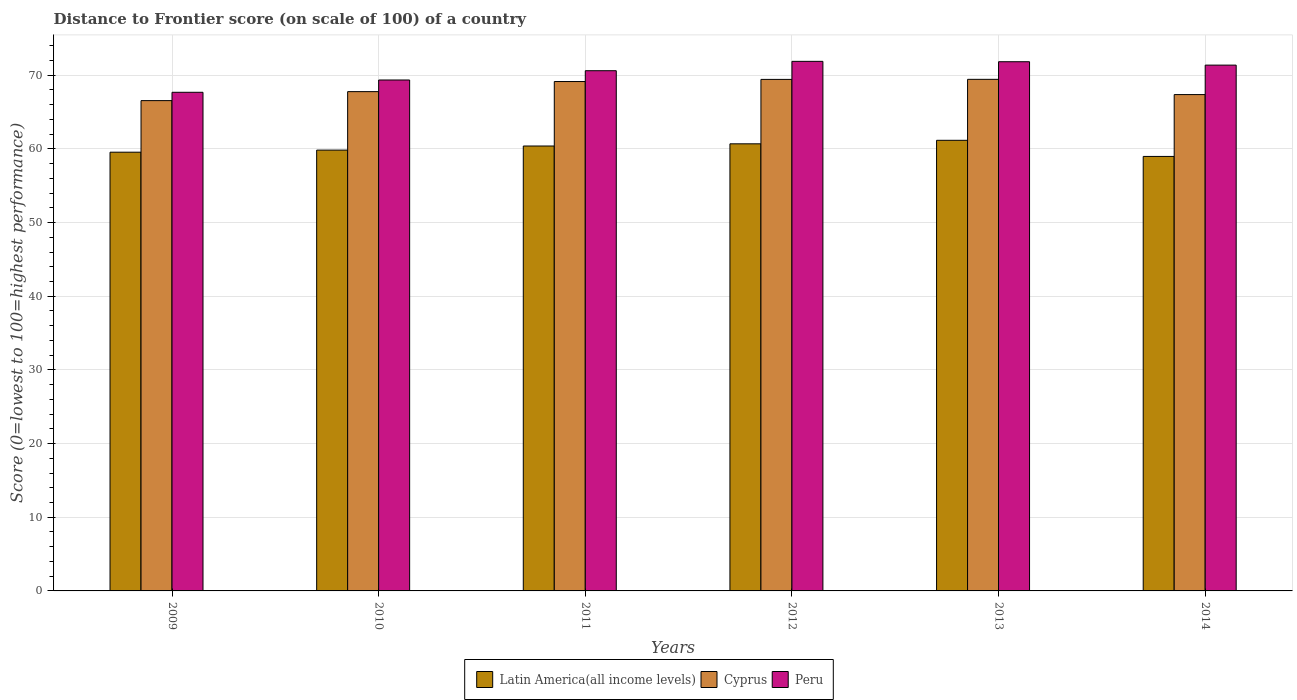How many different coloured bars are there?
Offer a very short reply. 3. How many groups of bars are there?
Offer a terse response. 6. How many bars are there on the 3rd tick from the left?
Provide a short and direct response. 3. How many bars are there on the 6th tick from the right?
Provide a succinct answer. 3. In how many cases, is the number of bars for a given year not equal to the number of legend labels?
Ensure brevity in your answer.  0. What is the distance to frontier score of in Latin America(all income levels) in 2012?
Offer a very short reply. 60.69. Across all years, what is the maximum distance to frontier score of in Peru?
Ensure brevity in your answer.  71.88. Across all years, what is the minimum distance to frontier score of in Peru?
Ensure brevity in your answer.  67.68. In which year was the distance to frontier score of in Latin America(all income levels) maximum?
Your answer should be very brief. 2013. What is the total distance to frontier score of in Cyprus in the graph?
Make the answer very short. 409.7. What is the difference between the distance to frontier score of in Peru in 2009 and that in 2014?
Provide a succinct answer. -3.69. What is the difference between the distance to frontier score of in Latin America(all income levels) in 2010 and the distance to frontier score of in Peru in 2012?
Provide a short and direct response. -12.05. What is the average distance to frontier score of in Latin America(all income levels) per year?
Offer a very short reply. 60.1. In the year 2012, what is the difference between the distance to frontier score of in Peru and distance to frontier score of in Latin America(all income levels)?
Provide a succinct answer. 11.19. In how many years, is the distance to frontier score of in Latin America(all income levels) greater than 68?
Offer a terse response. 0. What is the ratio of the distance to frontier score of in Peru in 2012 to that in 2014?
Your response must be concise. 1.01. Is the difference between the distance to frontier score of in Peru in 2009 and 2011 greater than the difference between the distance to frontier score of in Latin America(all income levels) in 2009 and 2011?
Your response must be concise. No. What is the difference between the highest and the second highest distance to frontier score of in Peru?
Ensure brevity in your answer.  0.05. What is the difference between the highest and the lowest distance to frontier score of in Peru?
Your answer should be very brief. 4.2. In how many years, is the distance to frontier score of in Latin America(all income levels) greater than the average distance to frontier score of in Latin America(all income levels) taken over all years?
Your answer should be very brief. 3. What does the 3rd bar from the left in 2011 represents?
Your response must be concise. Peru. What does the 3rd bar from the right in 2013 represents?
Your answer should be very brief. Latin America(all income levels). Is it the case that in every year, the sum of the distance to frontier score of in Latin America(all income levels) and distance to frontier score of in Peru is greater than the distance to frontier score of in Cyprus?
Ensure brevity in your answer.  Yes. How many bars are there?
Provide a short and direct response. 18. Are all the bars in the graph horizontal?
Give a very brief answer. No. How many years are there in the graph?
Offer a terse response. 6. What is the difference between two consecutive major ticks on the Y-axis?
Your response must be concise. 10. Are the values on the major ticks of Y-axis written in scientific E-notation?
Provide a succinct answer. No. Does the graph contain grids?
Offer a terse response. Yes. Where does the legend appear in the graph?
Your answer should be very brief. Bottom center. How are the legend labels stacked?
Provide a short and direct response. Horizontal. What is the title of the graph?
Make the answer very short. Distance to Frontier score (on scale of 100) of a country. What is the label or title of the Y-axis?
Your answer should be compact. Score (0=lowest to 100=highest performance). What is the Score (0=lowest to 100=highest performance) of Latin America(all income levels) in 2009?
Give a very brief answer. 59.55. What is the Score (0=lowest to 100=highest performance) in Cyprus in 2009?
Your answer should be very brief. 66.55. What is the Score (0=lowest to 100=highest performance) in Peru in 2009?
Give a very brief answer. 67.68. What is the Score (0=lowest to 100=highest performance) in Latin America(all income levels) in 2010?
Keep it short and to the point. 59.83. What is the Score (0=lowest to 100=highest performance) in Cyprus in 2010?
Make the answer very short. 67.77. What is the Score (0=lowest to 100=highest performance) of Peru in 2010?
Give a very brief answer. 69.35. What is the Score (0=lowest to 100=highest performance) in Latin America(all income levels) in 2011?
Provide a short and direct response. 60.39. What is the Score (0=lowest to 100=highest performance) in Cyprus in 2011?
Your response must be concise. 69.14. What is the Score (0=lowest to 100=highest performance) of Peru in 2011?
Offer a terse response. 70.61. What is the Score (0=lowest to 100=highest performance) of Latin America(all income levels) in 2012?
Your response must be concise. 60.69. What is the Score (0=lowest to 100=highest performance) of Cyprus in 2012?
Your answer should be very brief. 69.43. What is the Score (0=lowest to 100=highest performance) in Peru in 2012?
Provide a short and direct response. 71.88. What is the Score (0=lowest to 100=highest performance) in Latin America(all income levels) in 2013?
Make the answer very short. 61.16. What is the Score (0=lowest to 100=highest performance) in Cyprus in 2013?
Offer a very short reply. 69.44. What is the Score (0=lowest to 100=highest performance) in Peru in 2013?
Offer a terse response. 71.83. What is the Score (0=lowest to 100=highest performance) of Latin America(all income levels) in 2014?
Make the answer very short. 58.97. What is the Score (0=lowest to 100=highest performance) of Cyprus in 2014?
Make the answer very short. 67.37. What is the Score (0=lowest to 100=highest performance) in Peru in 2014?
Offer a terse response. 71.37. Across all years, what is the maximum Score (0=lowest to 100=highest performance) of Latin America(all income levels)?
Your response must be concise. 61.16. Across all years, what is the maximum Score (0=lowest to 100=highest performance) in Cyprus?
Give a very brief answer. 69.44. Across all years, what is the maximum Score (0=lowest to 100=highest performance) in Peru?
Keep it short and to the point. 71.88. Across all years, what is the minimum Score (0=lowest to 100=highest performance) in Latin America(all income levels)?
Your answer should be very brief. 58.97. Across all years, what is the minimum Score (0=lowest to 100=highest performance) in Cyprus?
Offer a terse response. 66.55. Across all years, what is the minimum Score (0=lowest to 100=highest performance) in Peru?
Offer a very short reply. 67.68. What is the total Score (0=lowest to 100=highest performance) in Latin America(all income levels) in the graph?
Ensure brevity in your answer.  360.6. What is the total Score (0=lowest to 100=highest performance) in Cyprus in the graph?
Your answer should be very brief. 409.7. What is the total Score (0=lowest to 100=highest performance) in Peru in the graph?
Your answer should be compact. 422.72. What is the difference between the Score (0=lowest to 100=highest performance) of Latin America(all income levels) in 2009 and that in 2010?
Offer a terse response. -0.28. What is the difference between the Score (0=lowest to 100=highest performance) of Cyprus in 2009 and that in 2010?
Offer a terse response. -1.22. What is the difference between the Score (0=lowest to 100=highest performance) of Peru in 2009 and that in 2010?
Offer a terse response. -1.67. What is the difference between the Score (0=lowest to 100=highest performance) of Latin America(all income levels) in 2009 and that in 2011?
Your answer should be compact. -0.84. What is the difference between the Score (0=lowest to 100=highest performance) in Cyprus in 2009 and that in 2011?
Ensure brevity in your answer.  -2.59. What is the difference between the Score (0=lowest to 100=highest performance) in Peru in 2009 and that in 2011?
Offer a terse response. -2.93. What is the difference between the Score (0=lowest to 100=highest performance) of Latin America(all income levels) in 2009 and that in 2012?
Provide a succinct answer. -1.14. What is the difference between the Score (0=lowest to 100=highest performance) in Cyprus in 2009 and that in 2012?
Provide a succinct answer. -2.88. What is the difference between the Score (0=lowest to 100=highest performance) in Peru in 2009 and that in 2012?
Make the answer very short. -4.2. What is the difference between the Score (0=lowest to 100=highest performance) in Latin America(all income levels) in 2009 and that in 2013?
Make the answer very short. -1.61. What is the difference between the Score (0=lowest to 100=highest performance) in Cyprus in 2009 and that in 2013?
Your response must be concise. -2.89. What is the difference between the Score (0=lowest to 100=highest performance) of Peru in 2009 and that in 2013?
Give a very brief answer. -4.15. What is the difference between the Score (0=lowest to 100=highest performance) of Latin America(all income levels) in 2009 and that in 2014?
Give a very brief answer. 0.57. What is the difference between the Score (0=lowest to 100=highest performance) in Cyprus in 2009 and that in 2014?
Provide a short and direct response. -0.82. What is the difference between the Score (0=lowest to 100=highest performance) in Peru in 2009 and that in 2014?
Your answer should be very brief. -3.69. What is the difference between the Score (0=lowest to 100=highest performance) of Latin America(all income levels) in 2010 and that in 2011?
Provide a succinct answer. -0.56. What is the difference between the Score (0=lowest to 100=highest performance) of Cyprus in 2010 and that in 2011?
Keep it short and to the point. -1.37. What is the difference between the Score (0=lowest to 100=highest performance) of Peru in 2010 and that in 2011?
Your answer should be compact. -1.26. What is the difference between the Score (0=lowest to 100=highest performance) of Latin America(all income levels) in 2010 and that in 2012?
Your answer should be compact. -0.85. What is the difference between the Score (0=lowest to 100=highest performance) in Cyprus in 2010 and that in 2012?
Your response must be concise. -1.66. What is the difference between the Score (0=lowest to 100=highest performance) in Peru in 2010 and that in 2012?
Your response must be concise. -2.53. What is the difference between the Score (0=lowest to 100=highest performance) in Latin America(all income levels) in 2010 and that in 2013?
Keep it short and to the point. -1.33. What is the difference between the Score (0=lowest to 100=highest performance) of Cyprus in 2010 and that in 2013?
Your response must be concise. -1.67. What is the difference between the Score (0=lowest to 100=highest performance) of Peru in 2010 and that in 2013?
Your answer should be very brief. -2.48. What is the difference between the Score (0=lowest to 100=highest performance) in Latin America(all income levels) in 2010 and that in 2014?
Make the answer very short. 0.86. What is the difference between the Score (0=lowest to 100=highest performance) in Cyprus in 2010 and that in 2014?
Offer a terse response. 0.4. What is the difference between the Score (0=lowest to 100=highest performance) of Peru in 2010 and that in 2014?
Offer a terse response. -2.02. What is the difference between the Score (0=lowest to 100=highest performance) in Latin America(all income levels) in 2011 and that in 2012?
Offer a terse response. -0.3. What is the difference between the Score (0=lowest to 100=highest performance) in Cyprus in 2011 and that in 2012?
Your response must be concise. -0.29. What is the difference between the Score (0=lowest to 100=highest performance) in Peru in 2011 and that in 2012?
Your response must be concise. -1.27. What is the difference between the Score (0=lowest to 100=highest performance) of Latin America(all income levels) in 2011 and that in 2013?
Provide a succinct answer. -0.77. What is the difference between the Score (0=lowest to 100=highest performance) in Peru in 2011 and that in 2013?
Your response must be concise. -1.22. What is the difference between the Score (0=lowest to 100=highest performance) in Latin America(all income levels) in 2011 and that in 2014?
Ensure brevity in your answer.  1.42. What is the difference between the Score (0=lowest to 100=highest performance) of Cyprus in 2011 and that in 2014?
Provide a succinct answer. 1.77. What is the difference between the Score (0=lowest to 100=highest performance) of Peru in 2011 and that in 2014?
Your response must be concise. -0.76. What is the difference between the Score (0=lowest to 100=highest performance) of Latin America(all income levels) in 2012 and that in 2013?
Your answer should be very brief. -0.48. What is the difference between the Score (0=lowest to 100=highest performance) in Cyprus in 2012 and that in 2013?
Give a very brief answer. -0.01. What is the difference between the Score (0=lowest to 100=highest performance) in Peru in 2012 and that in 2013?
Your response must be concise. 0.05. What is the difference between the Score (0=lowest to 100=highest performance) of Latin America(all income levels) in 2012 and that in 2014?
Ensure brevity in your answer.  1.71. What is the difference between the Score (0=lowest to 100=highest performance) in Cyprus in 2012 and that in 2014?
Give a very brief answer. 2.06. What is the difference between the Score (0=lowest to 100=highest performance) of Peru in 2012 and that in 2014?
Provide a succinct answer. 0.51. What is the difference between the Score (0=lowest to 100=highest performance) in Latin America(all income levels) in 2013 and that in 2014?
Offer a very short reply. 2.19. What is the difference between the Score (0=lowest to 100=highest performance) in Cyprus in 2013 and that in 2014?
Your response must be concise. 2.07. What is the difference between the Score (0=lowest to 100=highest performance) in Peru in 2013 and that in 2014?
Provide a succinct answer. 0.46. What is the difference between the Score (0=lowest to 100=highest performance) of Latin America(all income levels) in 2009 and the Score (0=lowest to 100=highest performance) of Cyprus in 2010?
Offer a terse response. -8.22. What is the difference between the Score (0=lowest to 100=highest performance) in Latin America(all income levels) in 2009 and the Score (0=lowest to 100=highest performance) in Peru in 2010?
Offer a very short reply. -9.8. What is the difference between the Score (0=lowest to 100=highest performance) of Cyprus in 2009 and the Score (0=lowest to 100=highest performance) of Peru in 2010?
Offer a very short reply. -2.8. What is the difference between the Score (0=lowest to 100=highest performance) of Latin America(all income levels) in 2009 and the Score (0=lowest to 100=highest performance) of Cyprus in 2011?
Your answer should be compact. -9.59. What is the difference between the Score (0=lowest to 100=highest performance) of Latin America(all income levels) in 2009 and the Score (0=lowest to 100=highest performance) of Peru in 2011?
Provide a succinct answer. -11.06. What is the difference between the Score (0=lowest to 100=highest performance) of Cyprus in 2009 and the Score (0=lowest to 100=highest performance) of Peru in 2011?
Keep it short and to the point. -4.06. What is the difference between the Score (0=lowest to 100=highest performance) in Latin America(all income levels) in 2009 and the Score (0=lowest to 100=highest performance) in Cyprus in 2012?
Your response must be concise. -9.88. What is the difference between the Score (0=lowest to 100=highest performance) in Latin America(all income levels) in 2009 and the Score (0=lowest to 100=highest performance) in Peru in 2012?
Provide a succinct answer. -12.33. What is the difference between the Score (0=lowest to 100=highest performance) of Cyprus in 2009 and the Score (0=lowest to 100=highest performance) of Peru in 2012?
Ensure brevity in your answer.  -5.33. What is the difference between the Score (0=lowest to 100=highest performance) in Latin America(all income levels) in 2009 and the Score (0=lowest to 100=highest performance) in Cyprus in 2013?
Provide a short and direct response. -9.89. What is the difference between the Score (0=lowest to 100=highest performance) in Latin America(all income levels) in 2009 and the Score (0=lowest to 100=highest performance) in Peru in 2013?
Provide a succinct answer. -12.28. What is the difference between the Score (0=lowest to 100=highest performance) of Cyprus in 2009 and the Score (0=lowest to 100=highest performance) of Peru in 2013?
Your response must be concise. -5.28. What is the difference between the Score (0=lowest to 100=highest performance) in Latin America(all income levels) in 2009 and the Score (0=lowest to 100=highest performance) in Cyprus in 2014?
Make the answer very short. -7.82. What is the difference between the Score (0=lowest to 100=highest performance) of Latin America(all income levels) in 2009 and the Score (0=lowest to 100=highest performance) of Peru in 2014?
Provide a short and direct response. -11.82. What is the difference between the Score (0=lowest to 100=highest performance) of Cyprus in 2009 and the Score (0=lowest to 100=highest performance) of Peru in 2014?
Make the answer very short. -4.82. What is the difference between the Score (0=lowest to 100=highest performance) of Latin America(all income levels) in 2010 and the Score (0=lowest to 100=highest performance) of Cyprus in 2011?
Ensure brevity in your answer.  -9.31. What is the difference between the Score (0=lowest to 100=highest performance) in Latin America(all income levels) in 2010 and the Score (0=lowest to 100=highest performance) in Peru in 2011?
Offer a very short reply. -10.78. What is the difference between the Score (0=lowest to 100=highest performance) of Cyprus in 2010 and the Score (0=lowest to 100=highest performance) of Peru in 2011?
Your answer should be compact. -2.84. What is the difference between the Score (0=lowest to 100=highest performance) in Latin America(all income levels) in 2010 and the Score (0=lowest to 100=highest performance) in Cyprus in 2012?
Keep it short and to the point. -9.6. What is the difference between the Score (0=lowest to 100=highest performance) of Latin America(all income levels) in 2010 and the Score (0=lowest to 100=highest performance) of Peru in 2012?
Give a very brief answer. -12.05. What is the difference between the Score (0=lowest to 100=highest performance) of Cyprus in 2010 and the Score (0=lowest to 100=highest performance) of Peru in 2012?
Offer a very short reply. -4.11. What is the difference between the Score (0=lowest to 100=highest performance) of Latin America(all income levels) in 2010 and the Score (0=lowest to 100=highest performance) of Cyprus in 2013?
Provide a succinct answer. -9.61. What is the difference between the Score (0=lowest to 100=highest performance) in Latin America(all income levels) in 2010 and the Score (0=lowest to 100=highest performance) in Peru in 2013?
Offer a terse response. -12. What is the difference between the Score (0=lowest to 100=highest performance) of Cyprus in 2010 and the Score (0=lowest to 100=highest performance) of Peru in 2013?
Provide a short and direct response. -4.06. What is the difference between the Score (0=lowest to 100=highest performance) of Latin America(all income levels) in 2010 and the Score (0=lowest to 100=highest performance) of Cyprus in 2014?
Give a very brief answer. -7.54. What is the difference between the Score (0=lowest to 100=highest performance) of Latin America(all income levels) in 2010 and the Score (0=lowest to 100=highest performance) of Peru in 2014?
Make the answer very short. -11.54. What is the difference between the Score (0=lowest to 100=highest performance) in Cyprus in 2010 and the Score (0=lowest to 100=highest performance) in Peru in 2014?
Provide a short and direct response. -3.6. What is the difference between the Score (0=lowest to 100=highest performance) in Latin America(all income levels) in 2011 and the Score (0=lowest to 100=highest performance) in Cyprus in 2012?
Your answer should be very brief. -9.04. What is the difference between the Score (0=lowest to 100=highest performance) of Latin America(all income levels) in 2011 and the Score (0=lowest to 100=highest performance) of Peru in 2012?
Your answer should be very brief. -11.49. What is the difference between the Score (0=lowest to 100=highest performance) of Cyprus in 2011 and the Score (0=lowest to 100=highest performance) of Peru in 2012?
Provide a succinct answer. -2.74. What is the difference between the Score (0=lowest to 100=highest performance) of Latin America(all income levels) in 2011 and the Score (0=lowest to 100=highest performance) of Cyprus in 2013?
Provide a succinct answer. -9.05. What is the difference between the Score (0=lowest to 100=highest performance) in Latin America(all income levels) in 2011 and the Score (0=lowest to 100=highest performance) in Peru in 2013?
Offer a terse response. -11.44. What is the difference between the Score (0=lowest to 100=highest performance) in Cyprus in 2011 and the Score (0=lowest to 100=highest performance) in Peru in 2013?
Provide a short and direct response. -2.69. What is the difference between the Score (0=lowest to 100=highest performance) in Latin America(all income levels) in 2011 and the Score (0=lowest to 100=highest performance) in Cyprus in 2014?
Your answer should be compact. -6.98. What is the difference between the Score (0=lowest to 100=highest performance) of Latin America(all income levels) in 2011 and the Score (0=lowest to 100=highest performance) of Peru in 2014?
Make the answer very short. -10.98. What is the difference between the Score (0=lowest to 100=highest performance) of Cyprus in 2011 and the Score (0=lowest to 100=highest performance) of Peru in 2014?
Your response must be concise. -2.23. What is the difference between the Score (0=lowest to 100=highest performance) of Latin America(all income levels) in 2012 and the Score (0=lowest to 100=highest performance) of Cyprus in 2013?
Offer a terse response. -8.75. What is the difference between the Score (0=lowest to 100=highest performance) in Latin America(all income levels) in 2012 and the Score (0=lowest to 100=highest performance) in Peru in 2013?
Give a very brief answer. -11.14. What is the difference between the Score (0=lowest to 100=highest performance) of Latin America(all income levels) in 2012 and the Score (0=lowest to 100=highest performance) of Cyprus in 2014?
Your answer should be compact. -6.68. What is the difference between the Score (0=lowest to 100=highest performance) in Latin America(all income levels) in 2012 and the Score (0=lowest to 100=highest performance) in Peru in 2014?
Provide a short and direct response. -10.68. What is the difference between the Score (0=lowest to 100=highest performance) in Cyprus in 2012 and the Score (0=lowest to 100=highest performance) in Peru in 2014?
Your response must be concise. -1.94. What is the difference between the Score (0=lowest to 100=highest performance) in Latin America(all income levels) in 2013 and the Score (0=lowest to 100=highest performance) in Cyprus in 2014?
Offer a very short reply. -6.21. What is the difference between the Score (0=lowest to 100=highest performance) in Latin America(all income levels) in 2013 and the Score (0=lowest to 100=highest performance) in Peru in 2014?
Offer a terse response. -10.21. What is the difference between the Score (0=lowest to 100=highest performance) of Cyprus in 2013 and the Score (0=lowest to 100=highest performance) of Peru in 2014?
Give a very brief answer. -1.93. What is the average Score (0=lowest to 100=highest performance) of Latin America(all income levels) per year?
Ensure brevity in your answer.  60.1. What is the average Score (0=lowest to 100=highest performance) of Cyprus per year?
Your answer should be very brief. 68.28. What is the average Score (0=lowest to 100=highest performance) of Peru per year?
Ensure brevity in your answer.  70.45. In the year 2009, what is the difference between the Score (0=lowest to 100=highest performance) in Latin America(all income levels) and Score (0=lowest to 100=highest performance) in Cyprus?
Provide a short and direct response. -7. In the year 2009, what is the difference between the Score (0=lowest to 100=highest performance) in Latin America(all income levels) and Score (0=lowest to 100=highest performance) in Peru?
Offer a terse response. -8.13. In the year 2009, what is the difference between the Score (0=lowest to 100=highest performance) in Cyprus and Score (0=lowest to 100=highest performance) in Peru?
Provide a succinct answer. -1.13. In the year 2010, what is the difference between the Score (0=lowest to 100=highest performance) of Latin America(all income levels) and Score (0=lowest to 100=highest performance) of Cyprus?
Give a very brief answer. -7.94. In the year 2010, what is the difference between the Score (0=lowest to 100=highest performance) in Latin America(all income levels) and Score (0=lowest to 100=highest performance) in Peru?
Provide a succinct answer. -9.52. In the year 2010, what is the difference between the Score (0=lowest to 100=highest performance) in Cyprus and Score (0=lowest to 100=highest performance) in Peru?
Provide a short and direct response. -1.58. In the year 2011, what is the difference between the Score (0=lowest to 100=highest performance) in Latin America(all income levels) and Score (0=lowest to 100=highest performance) in Cyprus?
Offer a very short reply. -8.75. In the year 2011, what is the difference between the Score (0=lowest to 100=highest performance) in Latin America(all income levels) and Score (0=lowest to 100=highest performance) in Peru?
Your answer should be compact. -10.22. In the year 2011, what is the difference between the Score (0=lowest to 100=highest performance) of Cyprus and Score (0=lowest to 100=highest performance) of Peru?
Offer a very short reply. -1.47. In the year 2012, what is the difference between the Score (0=lowest to 100=highest performance) in Latin America(all income levels) and Score (0=lowest to 100=highest performance) in Cyprus?
Your response must be concise. -8.74. In the year 2012, what is the difference between the Score (0=lowest to 100=highest performance) of Latin America(all income levels) and Score (0=lowest to 100=highest performance) of Peru?
Offer a very short reply. -11.19. In the year 2012, what is the difference between the Score (0=lowest to 100=highest performance) in Cyprus and Score (0=lowest to 100=highest performance) in Peru?
Keep it short and to the point. -2.45. In the year 2013, what is the difference between the Score (0=lowest to 100=highest performance) in Latin America(all income levels) and Score (0=lowest to 100=highest performance) in Cyprus?
Give a very brief answer. -8.28. In the year 2013, what is the difference between the Score (0=lowest to 100=highest performance) in Latin America(all income levels) and Score (0=lowest to 100=highest performance) in Peru?
Keep it short and to the point. -10.67. In the year 2013, what is the difference between the Score (0=lowest to 100=highest performance) in Cyprus and Score (0=lowest to 100=highest performance) in Peru?
Your answer should be very brief. -2.39. In the year 2014, what is the difference between the Score (0=lowest to 100=highest performance) of Latin America(all income levels) and Score (0=lowest to 100=highest performance) of Cyprus?
Offer a very short reply. -8.4. In the year 2014, what is the difference between the Score (0=lowest to 100=highest performance) of Latin America(all income levels) and Score (0=lowest to 100=highest performance) of Peru?
Ensure brevity in your answer.  -12.4. What is the ratio of the Score (0=lowest to 100=highest performance) in Cyprus in 2009 to that in 2010?
Give a very brief answer. 0.98. What is the ratio of the Score (0=lowest to 100=highest performance) of Peru in 2009 to that in 2010?
Offer a very short reply. 0.98. What is the ratio of the Score (0=lowest to 100=highest performance) of Latin America(all income levels) in 2009 to that in 2011?
Provide a succinct answer. 0.99. What is the ratio of the Score (0=lowest to 100=highest performance) in Cyprus in 2009 to that in 2011?
Make the answer very short. 0.96. What is the ratio of the Score (0=lowest to 100=highest performance) of Peru in 2009 to that in 2011?
Your answer should be compact. 0.96. What is the ratio of the Score (0=lowest to 100=highest performance) in Latin America(all income levels) in 2009 to that in 2012?
Offer a very short reply. 0.98. What is the ratio of the Score (0=lowest to 100=highest performance) in Cyprus in 2009 to that in 2012?
Your answer should be very brief. 0.96. What is the ratio of the Score (0=lowest to 100=highest performance) of Peru in 2009 to that in 2012?
Your response must be concise. 0.94. What is the ratio of the Score (0=lowest to 100=highest performance) of Latin America(all income levels) in 2009 to that in 2013?
Offer a very short reply. 0.97. What is the ratio of the Score (0=lowest to 100=highest performance) of Cyprus in 2009 to that in 2013?
Make the answer very short. 0.96. What is the ratio of the Score (0=lowest to 100=highest performance) of Peru in 2009 to that in 2013?
Your answer should be very brief. 0.94. What is the ratio of the Score (0=lowest to 100=highest performance) in Latin America(all income levels) in 2009 to that in 2014?
Give a very brief answer. 1.01. What is the ratio of the Score (0=lowest to 100=highest performance) in Cyprus in 2009 to that in 2014?
Offer a very short reply. 0.99. What is the ratio of the Score (0=lowest to 100=highest performance) of Peru in 2009 to that in 2014?
Provide a succinct answer. 0.95. What is the ratio of the Score (0=lowest to 100=highest performance) in Latin America(all income levels) in 2010 to that in 2011?
Provide a short and direct response. 0.99. What is the ratio of the Score (0=lowest to 100=highest performance) in Cyprus in 2010 to that in 2011?
Provide a short and direct response. 0.98. What is the ratio of the Score (0=lowest to 100=highest performance) of Peru in 2010 to that in 2011?
Provide a succinct answer. 0.98. What is the ratio of the Score (0=lowest to 100=highest performance) of Latin America(all income levels) in 2010 to that in 2012?
Your answer should be compact. 0.99. What is the ratio of the Score (0=lowest to 100=highest performance) of Cyprus in 2010 to that in 2012?
Your answer should be compact. 0.98. What is the ratio of the Score (0=lowest to 100=highest performance) in Peru in 2010 to that in 2012?
Offer a very short reply. 0.96. What is the ratio of the Score (0=lowest to 100=highest performance) in Latin America(all income levels) in 2010 to that in 2013?
Your answer should be compact. 0.98. What is the ratio of the Score (0=lowest to 100=highest performance) of Cyprus in 2010 to that in 2013?
Your answer should be very brief. 0.98. What is the ratio of the Score (0=lowest to 100=highest performance) of Peru in 2010 to that in 2013?
Offer a terse response. 0.97. What is the ratio of the Score (0=lowest to 100=highest performance) in Latin America(all income levels) in 2010 to that in 2014?
Ensure brevity in your answer.  1.01. What is the ratio of the Score (0=lowest to 100=highest performance) of Cyprus in 2010 to that in 2014?
Offer a terse response. 1.01. What is the ratio of the Score (0=lowest to 100=highest performance) in Peru in 2010 to that in 2014?
Your answer should be compact. 0.97. What is the ratio of the Score (0=lowest to 100=highest performance) of Latin America(all income levels) in 2011 to that in 2012?
Provide a succinct answer. 1. What is the ratio of the Score (0=lowest to 100=highest performance) of Cyprus in 2011 to that in 2012?
Give a very brief answer. 1. What is the ratio of the Score (0=lowest to 100=highest performance) in Peru in 2011 to that in 2012?
Offer a very short reply. 0.98. What is the ratio of the Score (0=lowest to 100=highest performance) of Latin America(all income levels) in 2011 to that in 2013?
Provide a succinct answer. 0.99. What is the ratio of the Score (0=lowest to 100=highest performance) of Cyprus in 2011 to that in 2013?
Offer a terse response. 1. What is the ratio of the Score (0=lowest to 100=highest performance) in Peru in 2011 to that in 2013?
Your answer should be compact. 0.98. What is the ratio of the Score (0=lowest to 100=highest performance) of Latin America(all income levels) in 2011 to that in 2014?
Your answer should be very brief. 1.02. What is the ratio of the Score (0=lowest to 100=highest performance) in Cyprus in 2011 to that in 2014?
Provide a succinct answer. 1.03. What is the ratio of the Score (0=lowest to 100=highest performance) in Latin America(all income levels) in 2012 to that in 2013?
Give a very brief answer. 0.99. What is the ratio of the Score (0=lowest to 100=highest performance) of Peru in 2012 to that in 2013?
Your answer should be very brief. 1. What is the ratio of the Score (0=lowest to 100=highest performance) of Cyprus in 2012 to that in 2014?
Make the answer very short. 1.03. What is the ratio of the Score (0=lowest to 100=highest performance) in Peru in 2012 to that in 2014?
Provide a short and direct response. 1.01. What is the ratio of the Score (0=lowest to 100=highest performance) in Latin America(all income levels) in 2013 to that in 2014?
Your answer should be compact. 1.04. What is the ratio of the Score (0=lowest to 100=highest performance) of Cyprus in 2013 to that in 2014?
Give a very brief answer. 1.03. What is the ratio of the Score (0=lowest to 100=highest performance) of Peru in 2013 to that in 2014?
Your response must be concise. 1.01. What is the difference between the highest and the second highest Score (0=lowest to 100=highest performance) of Latin America(all income levels)?
Offer a terse response. 0.48. What is the difference between the highest and the second highest Score (0=lowest to 100=highest performance) of Cyprus?
Ensure brevity in your answer.  0.01. What is the difference between the highest and the lowest Score (0=lowest to 100=highest performance) in Latin America(all income levels)?
Your response must be concise. 2.19. What is the difference between the highest and the lowest Score (0=lowest to 100=highest performance) of Cyprus?
Your response must be concise. 2.89. What is the difference between the highest and the lowest Score (0=lowest to 100=highest performance) of Peru?
Keep it short and to the point. 4.2. 